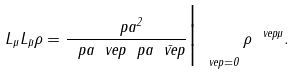<formula> <loc_0><loc_0><loc_500><loc_500>L _ { \mu } L _ { \bar { \mu } } \rho = \frac { \ p a ^ { 2 } } { \ p a \ v e p \ p a \bar { \ v e p } } \Big | _ { \ v e p = 0 } \, \rho ^ { \ v e p \mu } .</formula> 